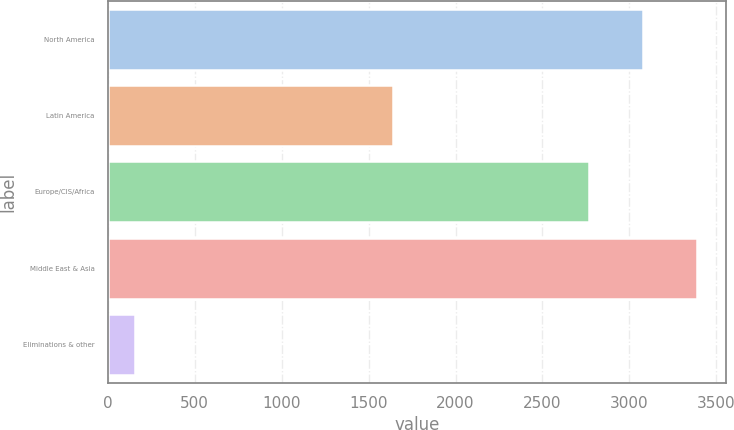<chart> <loc_0><loc_0><loc_500><loc_500><bar_chart><fcel>North America<fcel>Latin America<fcel>Europe/CIS/Africa<fcel>Middle East & Asia<fcel>Eliminations & other<nl><fcel>3076.5<fcel>1639<fcel>2765<fcel>3388<fcel>158<nl></chart> 